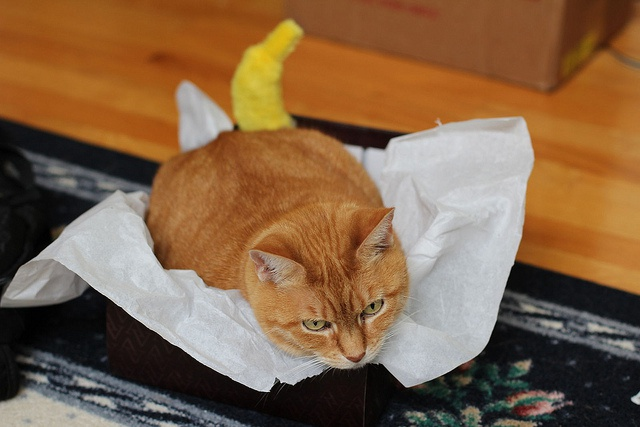Describe the objects in this image and their specific colors. I can see cat in brown, tan, and maroon tones and banana in brown, gold, olive, and tan tones in this image. 